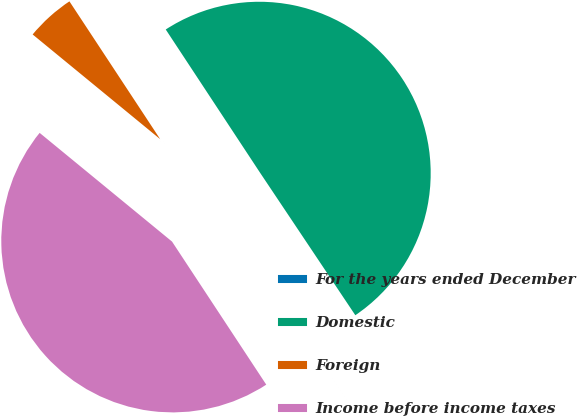<chart> <loc_0><loc_0><loc_500><loc_500><pie_chart><fcel>For the years ended December<fcel>Domestic<fcel>Foreign<fcel>Income before income taxes<nl><fcel>0.11%<fcel>49.89%<fcel>4.79%<fcel>45.21%<nl></chart> 